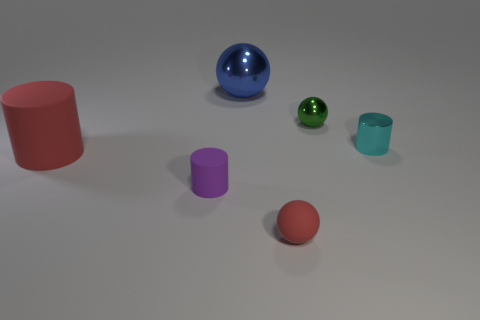Add 4 tiny green spheres. How many objects exist? 10 Add 4 big purple blocks. How many big purple blocks exist? 4 Subtract 1 purple cylinders. How many objects are left? 5 Subtract all red matte spheres. Subtract all purple shiny cylinders. How many objects are left? 5 Add 3 matte spheres. How many matte spheres are left? 4 